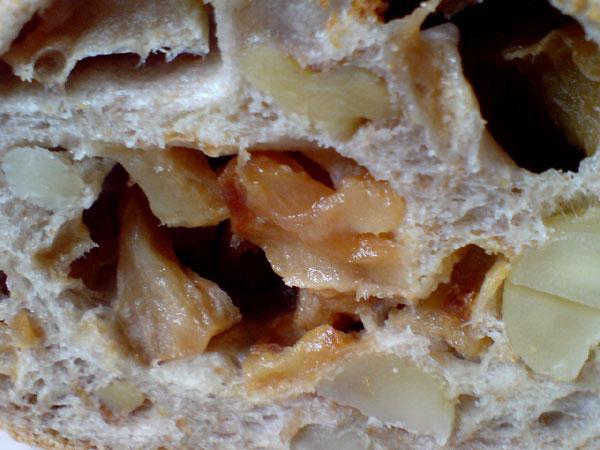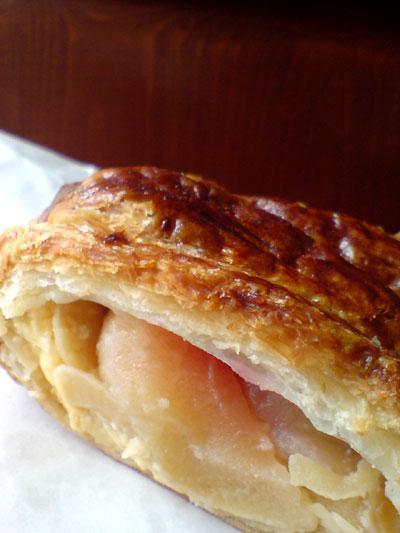The first image is the image on the left, the second image is the image on the right. Evaluate the accuracy of this statement regarding the images: "There are no more than five pastries.". Is it true? Answer yes or no. Yes. The first image is the image on the left, the second image is the image on the right. Considering the images on both sides, is "One image contains exactly two round roll-type items displayed horizontally and side-by-side." valid? Answer yes or no. No. 